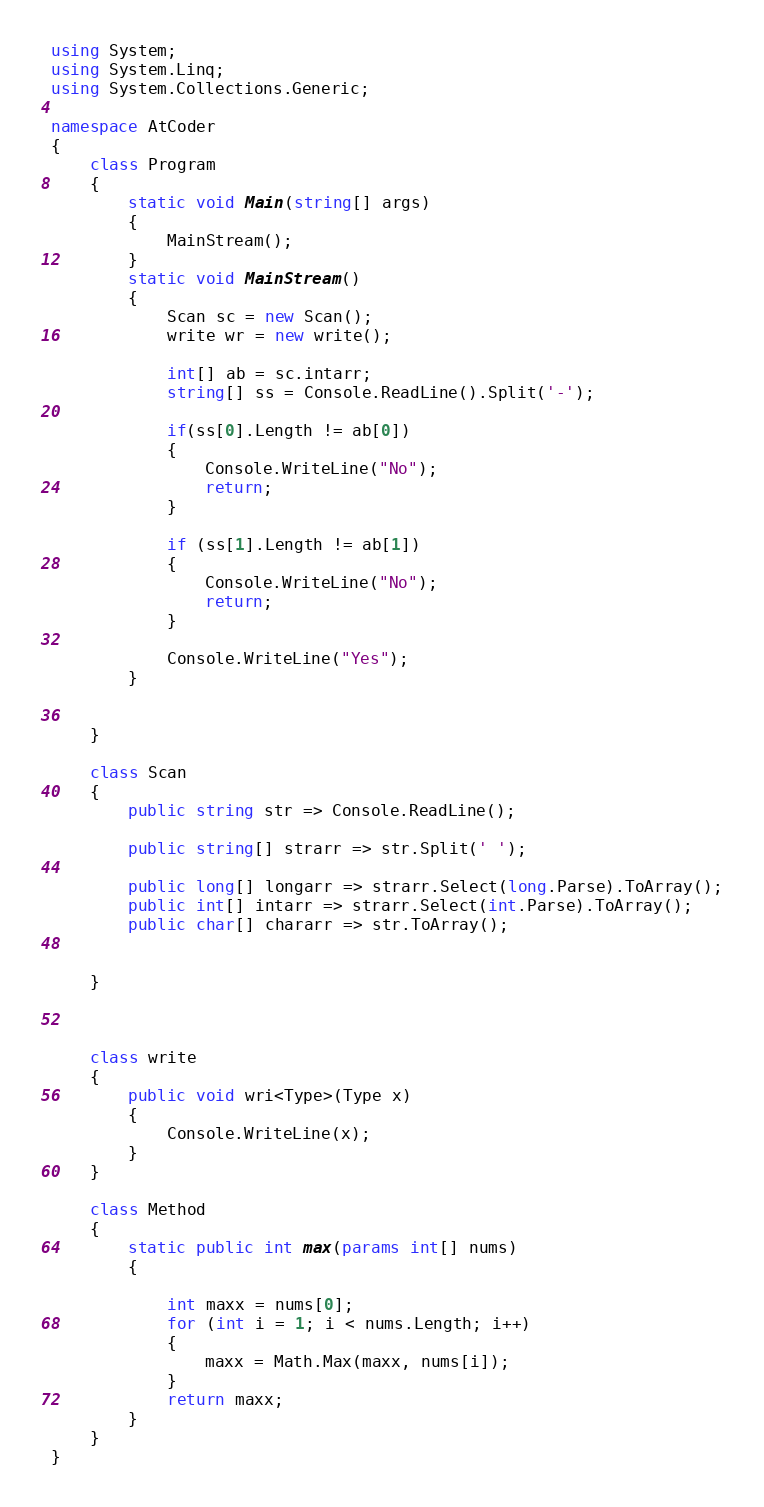Convert code to text. <code><loc_0><loc_0><loc_500><loc_500><_C#_>using System;
using System.Linq;
using System.Collections.Generic;

namespace AtCoder
{
    class Program
    {
        static void Main(string[] args)
        {
            MainStream();
        }
        static void MainStream()
        {
            Scan sc = new Scan();
            write wr = new write();

            int[] ab = sc.intarr;
            string[] ss = Console.ReadLine().Split('-');

            if(ss[0].Length != ab[0])
            {
                Console.WriteLine("No");
                return;
            }

            if (ss[1].Length != ab[1])
            {
                Console.WriteLine("No");
                return;
            }

            Console.WriteLine("Yes");
        }


    }

    class Scan
    {
        public string str => Console.ReadLine();

        public string[] strarr => str.Split(' ');

        public long[] longarr => strarr.Select(long.Parse).ToArray();
        public int[] intarr => strarr.Select(int.Parse).ToArray();
        public char[] chararr => str.ToArray();


    }



    class write
    {
        public void wri<Type>(Type x)
        {
            Console.WriteLine(x);
        }
    }

    class Method
    {
        static public int max(params int[] nums)
        {

            int maxx = nums[0];
            for (int i = 1; i < nums.Length; i++)
            {
                maxx = Math.Max(maxx, nums[i]);
            }
            return maxx;
        }
    }
}
</code> 